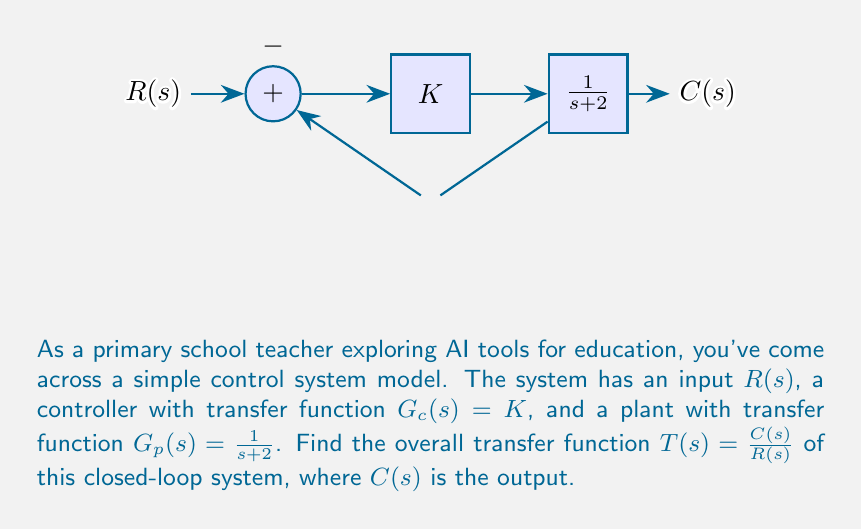Help me with this question. To find the transfer function of this closed-loop system, we'll follow these steps:

1) First, let's identify the forward path and feedback path:
   - Forward path: $G(s) = G_c(s) \cdot G_p(s) = K \cdot \frac{1}{s+2}$
   - Feedback path: $H(s) = 1$ (unity feedback)

2) The closed-loop transfer function is given by:

   $$T(s) = \frac{G(s)}{1 + G(s)H(s)}$$

3) Substituting our values:

   $$T(s) = \frac{K \cdot \frac{1}{s+2}}{1 + K \cdot \frac{1}{s+2} \cdot 1}$$

4) Simplify the numerator and denominator:

   $$T(s) = \frac{\frac{K}{s+2}}{\frac{s+2}{s+2} + \frac{K}{s+2}}$$

5) Find a common denominator in the denominator:

   $$T(s) = \frac{\frac{K}{s+2}}{\frac{s+2+K}{s+2}}$$

6) The $(s+2)$ terms cancel out:

   $$T(s) = \frac{K}{s+2+K}$$

This is the final transfer function of the closed-loop system.
Answer: $$T(s) = \frac{K}{s+2+K}$$ 